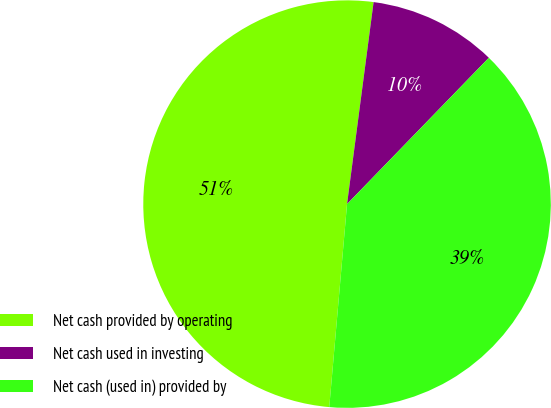Convert chart. <chart><loc_0><loc_0><loc_500><loc_500><pie_chart><fcel>Net cash provided by operating<fcel>Net cash used in investing<fcel>Net cash (used in) provided by<nl><fcel>50.69%<fcel>10.17%<fcel>39.14%<nl></chart> 